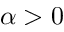Convert formula to latex. <formula><loc_0><loc_0><loc_500><loc_500>\alpha > 0</formula> 